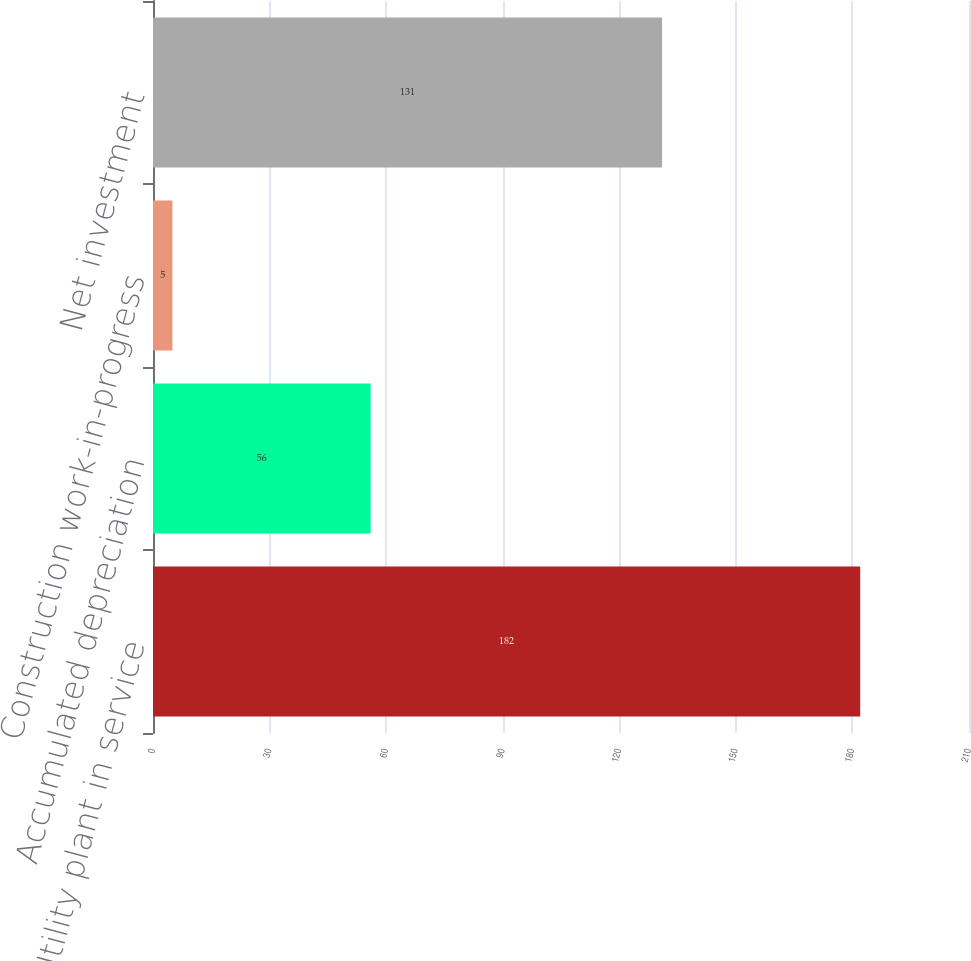<chart> <loc_0><loc_0><loc_500><loc_500><bar_chart><fcel>Utility plant in service<fcel>Accumulated depreciation<fcel>Construction work-in-progress<fcel>Net investment<nl><fcel>182<fcel>56<fcel>5<fcel>131<nl></chart> 